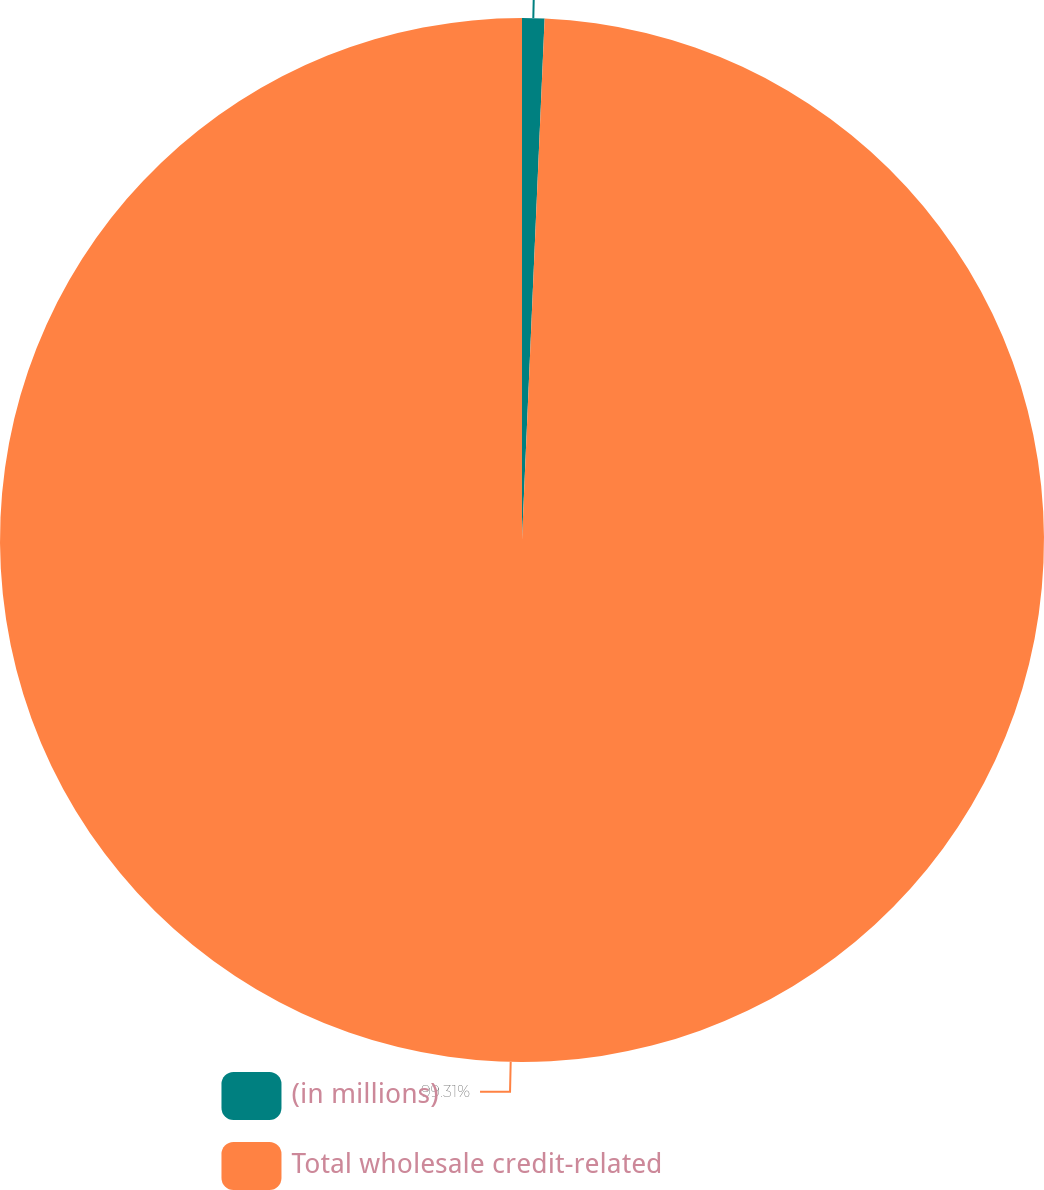<chart> <loc_0><loc_0><loc_500><loc_500><pie_chart><fcel>(in millions)<fcel>Total wholesale credit-related<nl><fcel>0.69%<fcel>99.31%<nl></chart> 